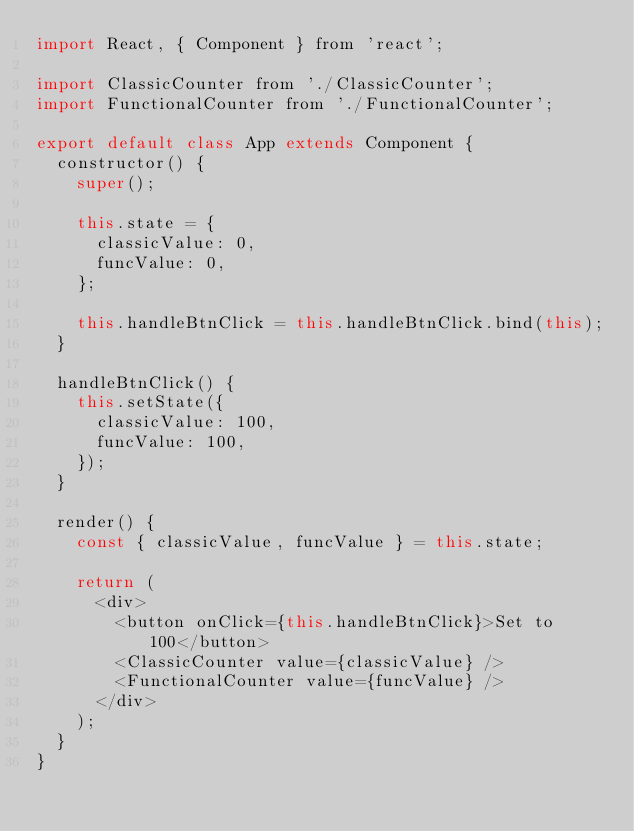Convert code to text. <code><loc_0><loc_0><loc_500><loc_500><_JavaScript_>import React, { Component } from 'react';

import ClassicCounter from './ClassicCounter';
import FunctionalCounter from './FunctionalCounter';

export default class App extends Component {
  constructor() {
    super();

    this.state = {
      classicValue: 0,
      funcValue: 0,
    };

    this.handleBtnClick = this.handleBtnClick.bind(this);
  }

  handleBtnClick() {
    this.setState({
      classicValue: 100,
      funcValue: 100,
    });
  }

  render() {
    const { classicValue, funcValue } = this.state;

    return (
      <div>
        <button onClick={this.handleBtnClick}>Set to 100</button>
        <ClassicCounter value={classicValue} />
        <FunctionalCounter value={funcValue} />
      </div>
    );
  }
}
</code> 